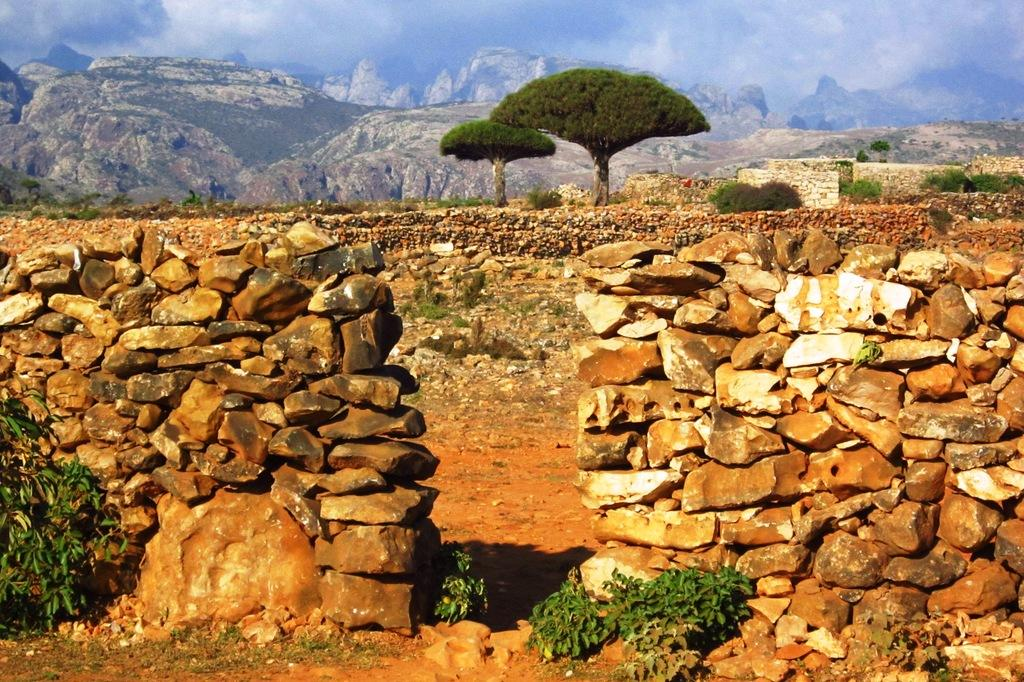What type of structure is present in the image? There is a stone wall in the image. What type of vegetation can be seen in the image? There are plants and trees in the image. What geographical feature is visible in the image? There are mountains in the image. What part of the natural environment is visible in the image? The sky is visible in the image. Where is the chair located in the image? There is no chair present in the image. What type of pickle can be seen growing on the trees in the image? There are no pickles present in the image, as it features plants and trees in a natural setting. 